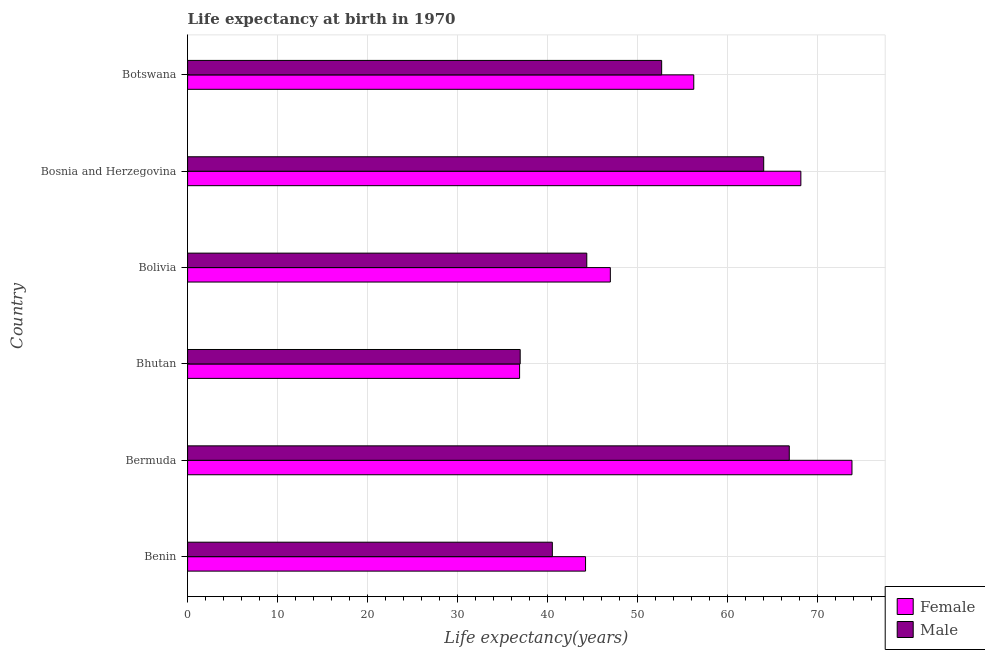How many groups of bars are there?
Your answer should be compact. 6. Are the number of bars per tick equal to the number of legend labels?
Provide a short and direct response. Yes. Are the number of bars on each tick of the Y-axis equal?
Your answer should be very brief. Yes. How many bars are there on the 5th tick from the top?
Your response must be concise. 2. What is the label of the 1st group of bars from the top?
Your answer should be very brief. Botswana. What is the life expectancy(female) in Benin?
Provide a succinct answer. 44.24. Across all countries, what is the maximum life expectancy(male)?
Provide a short and direct response. 66.89. Across all countries, what is the minimum life expectancy(male)?
Give a very brief answer. 36.97. In which country was the life expectancy(male) maximum?
Ensure brevity in your answer.  Bermuda. In which country was the life expectancy(female) minimum?
Your answer should be compact. Bhutan. What is the total life expectancy(female) in the graph?
Provide a succinct answer. 326.45. What is the difference between the life expectancy(male) in Bermuda and that in Bosnia and Herzegovina?
Give a very brief answer. 2.84. What is the difference between the life expectancy(male) in Botswana and the life expectancy(female) in Bolivia?
Give a very brief answer. 5.7. What is the average life expectancy(female) per country?
Give a very brief answer. 54.41. What is the difference between the life expectancy(male) and life expectancy(female) in Botswana?
Your answer should be very brief. -3.57. What is the ratio of the life expectancy(female) in Bosnia and Herzegovina to that in Botswana?
Provide a succinct answer. 1.21. Is the life expectancy(female) in Benin less than that in Bermuda?
Provide a short and direct response. Yes. Is the difference between the life expectancy(male) in Bosnia and Herzegovina and Botswana greater than the difference between the life expectancy(female) in Bosnia and Herzegovina and Botswana?
Give a very brief answer. No. What is the difference between the highest and the second highest life expectancy(female)?
Offer a very short reply. 5.68. What is the difference between the highest and the lowest life expectancy(female)?
Offer a terse response. 36.95. What does the 2nd bar from the bottom in Bermuda represents?
Provide a short and direct response. Male. How many bars are there?
Offer a very short reply. 12. How many countries are there in the graph?
Give a very brief answer. 6. Does the graph contain any zero values?
Make the answer very short. No. How many legend labels are there?
Your answer should be very brief. 2. What is the title of the graph?
Provide a succinct answer. Life expectancy at birth in 1970. What is the label or title of the X-axis?
Your answer should be very brief. Life expectancy(years). What is the Life expectancy(years) in Female in Benin?
Your response must be concise. 44.24. What is the Life expectancy(years) in Male in Benin?
Provide a succinct answer. 40.55. What is the Life expectancy(years) in Female in Bermuda?
Provide a short and direct response. 73.86. What is the Life expectancy(years) of Male in Bermuda?
Ensure brevity in your answer.  66.89. What is the Life expectancy(years) of Female in Bhutan?
Ensure brevity in your answer.  36.91. What is the Life expectancy(years) in Male in Bhutan?
Offer a very short reply. 36.97. What is the Life expectancy(years) in Female in Bolivia?
Keep it short and to the point. 47. What is the Life expectancy(years) in Male in Bolivia?
Your answer should be compact. 44.38. What is the Life expectancy(years) in Female in Bosnia and Herzegovina?
Provide a short and direct response. 68.18. What is the Life expectancy(years) in Male in Bosnia and Herzegovina?
Your answer should be very brief. 64.05. What is the Life expectancy(years) of Female in Botswana?
Ensure brevity in your answer.  56.27. What is the Life expectancy(years) of Male in Botswana?
Offer a very short reply. 52.7. Across all countries, what is the maximum Life expectancy(years) in Female?
Make the answer very short. 73.86. Across all countries, what is the maximum Life expectancy(years) in Male?
Your answer should be compact. 66.89. Across all countries, what is the minimum Life expectancy(years) of Female?
Make the answer very short. 36.91. Across all countries, what is the minimum Life expectancy(years) in Male?
Provide a short and direct response. 36.97. What is the total Life expectancy(years) of Female in the graph?
Your response must be concise. 326.45. What is the total Life expectancy(years) in Male in the graph?
Provide a succinct answer. 305.54. What is the difference between the Life expectancy(years) of Female in Benin and that in Bermuda?
Your answer should be very brief. -29.62. What is the difference between the Life expectancy(years) of Male in Benin and that in Bermuda?
Give a very brief answer. -26.34. What is the difference between the Life expectancy(years) in Female in Benin and that in Bhutan?
Keep it short and to the point. 7.33. What is the difference between the Life expectancy(years) in Male in Benin and that in Bhutan?
Keep it short and to the point. 3.58. What is the difference between the Life expectancy(years) in Female in Benin and that in Bolivia?
Your answer should be very brief. -2.76. What is the difference between the Life expectancy(years) in Male in Benin and that in Bolivia?
Provide a succinct answer. -3.83. What is the difference between the Life expectancy(years) in Female in Benin and that in Bosnia and Herzegovina?
Your response must be concise. -23.94. What is the difference between the Life expectancy(years) of Male in Benin and that in Bosnia and Herzegovina?
Offer a very short reply. -23.5. What is the difference between the Life expectancy(years) of Female in Benin and that in Botswana?
Make the answer very short. -12.03. What is the difference between the Life expectancy(years) of Male in Benin and that in Botswana?
Provide a short and direct response. -12.15. What is the difference between the Life expectancy(years) of Female in Bermuda and that in Bhutan?
Provide a short and direct response. 36.95. What is the difference between the Life expectancy(years) in Male in Bermuda and that in Bhutan?
Offer a very short reply. 29.92. What is the difference between the Life expectancy(years) of Female in Bermuda and that in Bolivia?
Give a very brief answer. 26.86. What is the difference between the Life expectancy(years) of Male in Bermuda and that in Bolivia?
Make the answer very short. 22.51. What is the difference between the Life expectancy(years) of Female in Bermuda and that in Bosnia and Herzegovina?
Offer a very short reply. 5.68. What is the difference between the Life expectancy(years) in Male in Bermuda and that in Bosnia and Herzegovina?
Provide a succinct answer. 2.84. What is the difference between the Life expectancy(years) in Female in Bermuda and that in Botswana?
Your answer should be compact. 17.59. What is the difference between the Life expectancy(years) of Male in Bermuda and that in Botswana?
Your answer should be compact. 14.19. What is the difference between the Life expectancy(years) of Female in Bhutan and that in Bolivia?
Your answer should be very brief. -10.09. What is the difference between the Life expectancy(years) of Male in Bhutan and that in Bolivia?
Offer a terse response. -7.4. What is the difference between the Life expectancy(years) of Female in Bhutan and that in Bosnia and Herzegovina?
Ensure brevity in your answer.  -31.27. What is the difference between the Life expectancy(years) in Male in Bhutan and that in Bosnia and Herzegovina?
Keep it short and to the point. -27.07. What is the difference between the Life expectancy(years) in Female in Bhutan and that in Botswana?
Ensure brevity in your answer.  -19.36. What is the difference between the Life expectancy(years) in Male in Bhutan and that in Botswana?
Provide a succinct answer. -15.73. What is the difference between the Life expectancy(years) in Female in Bolivia and that in Bosnia and Herzegovina?
Keep it short and to the point. -21.18. What is the difference between the Life expectancy(years) of Male in Bolivia and that in Bosnia and Herzegovina?
Your answer should be compact. -19.67. What is the difference between the Life expectancy(years) of Female in Bolivia and that in Botswana?
Your response must be concise. -9.28. What is the difference between the Life expectancy(years) in Male in Bolivia and that in Botswana?
Give a very brief answer. -8.32. What is the difference between the Life expectancy(years) in Female in Bosnia and Herzegovina and that in Botswana?
Keep it short and to the point. 11.9. What is the difference between the Life expectancy(years) in Male in Bosnia and Herzegovina and that in Botswana?
Offer a terse response. 11.35. What is the difference between the Life expectancy(years) of Female in Benin and the Life expectancy(years) of Male in Bermuda?
Ensure brevity in your answer.  -22.65. What is the difference between the Life expectancy(years) in Female in Benin and the Life expectancy(years) in Male in Bhutan?
Your response must be concise. 7.27. What is the difference between the Life expectancy(years) in Female in Benin and the Life expectancy(years) in Male in Bolivia?
Give a very brief answer. -0.14. What is the difference between the Life expectancy(years) of Female in Benin and the Life expectancy(years) of Male in Bosnia and Herzegovina?
Your answer should be very brief. -19.81. What is the difference between the Life expectancy(years) of Female in Benin and the Life expectancy(years) of Male in Botswana?
Ensure brevity in your answer.  -8.46. What is the difference between the Life expectancy(years) of Female in Bermuda and the Life expectancy(years) of Male in Bhutan?
Provide a succinct answer. 36.89. What is the difference between the Life expectancy(years) of Female in Bermuda and the Life expectancy(years) of Male in Bolivia?
Your response must be concise. 29.48. What is the difference between the Life expectancy(years) in Female in Bermuda and the Life expectancy(years) in Male in Bosnia and Herzegovina?
Your answer should be very brief. 9.81. What is the difference between the Life expectancy(years) of Female in Bermuda and the Life expectancy(years) of Male in Botswana?
Provide a succinct answer. 21.16. What is the difference between the Life expectancy(years) in Female in Bhutan and the Life expectancy(years) in Male in Bolivia?
Your answer should be compact. -7.47. What is the difference between the Life expectancy(years) of Female in Bhutan and the Life expectancy(years) of Male in Bosnia and Herzegovina?
Ensure brevity in your answer.  -27.14. What is the difference between the Life expectancy(years) of Female in Bhutan and the Life expectancy(years) of Male in Botswana?
Ensure brevity in your answer.  -15.79. What is the difference between the Life expectancy(years) in Female in Bolivia and the Life expectancy(years) in Male in Bosnia and Herzegovina?
Offer a very short reply. -17.05. What is the difference between the Life expectancy(years) of Female in Bolivia and the Life expectancy(years) of Male in Botswana?
Your answer should be very brief. -5.71. What is the difference between the Life expectancy(years) in Female in Bosnia and Herzegovina and the Life expectancy(years) in Male in Botswana?
Offer a very short reply. 15.47. What is the average Life expectancy(years) of Female per country?
Make the answer very short. 54.41. What is the average Life expectancy(years) of Male per country?
Your answer should be compact. 50.92. What is the difference between the Life expectancy(years) of Female and Life expectancy(years) of Male in Benin?
Provide a succinct answer. 3.69. What is the difference between the Life expectancy(years) of Female and Life expectancy(years) of Male in Bermuda?
Offer a very short reply. 6.97. What is the difference between the Life expectancy(years) in Female and Life expectancy(years) in Male in Bhutan?
Make the answer very short. -0.07. What is the difference between the Life expectancy(years) of Female and Life expectancy(years) of Male in Bolivia?
Make the answer very short. 2.62. What is the difference between the Life expectancy(years) in Female and Life expectancy(years) in Male in Bosnia and Herzegovina?
Your answer should be compact. 4.13. What is the difference between the Life expectancy(years) in Female and Life expectancy(years) in Male in Botswana?
Keep it short and to the point. 3.57. What is the ratio of the Life expectancy(years) of Female in Benin to that in Bermuda?
Offer a terse response. 0.6. What is the ratio of the Life expectancy(years) in Male in Benin to that in Bermuda?
Keep it short and to the point. 0.61. What is the ratio of the Life expectancy(years) of Female in Benin to that in Bhutan?
Offer a terse response. 1.2. What is the ratio of the Life expectancy(years) of Male in Benin to that in Bhutan?
Offer a very short reply. 1.1. What is the ratio of the Life expectancy(years) of Female in Benin to that in Bolivia?
Your answer should be very brief. 0.94. What is the ratio of the Life expectancy(years) in Male in Benin to that in Bolivia?
Offer a terse response. 0.91. What is the ratio of the Life expectancy(years) of Female in Benin to that in Bosnia and Herzegovina?
Make the answer very short. 0.65. What is the ratio of the Life expectancy(years) of Male in Benin to that in Bosnia and Herzegovina?
Give a very brief answer. 0.63. What is the ratio of the Life expectancy(years) of Female in Benin to that in Botswana?
Your answer should be compact. 0.79. What is the ratio of the Life expectancy(years) of Male in Benin to that in Botswana?
Give a very brief answer. 0.77. What is the ratio of the Life expectancy(years) in Female in Bermuda to that in Bhutan?
Provide a short and direct response. 2. What is the ratio of the Life expectancy(years) in Male in Bermuda to that in Bhutan?
Offer a terse response. 1.81. What is the ratio of the Life expectancy(years) in Female in Bermuda to that in Bolivia?
Give a very brief answer. 1.57. What is the ratio of the Life expectancy(years) in Male in Bermuda to that in Bolivia?
Make the answer very short. 1.51. What is the ratio of the Life expectancy(years) in Female in Bermuda to that in Bosnia and Herzegovina?
Ensure brevity in your answer.  1.08. What is the ratio of the Life expectancy(years) in Male in Bermuda to that in Bosnia and Herzegovina?
Offer a terse response. 1.04. What is the ratio of the Life expectancy(years) of Female in Bermuda to that in Botswana?
Make the answer very short. 1.31. What is the ratio of the Life expectancy(years) of Male in Bermuda to that in Botswana?
Your answer should be very brief. 1.27. What is the ratio of the Life expectancy(years) in Female in Bhutan to that in Bolivia?
Your response must be concise. 0.79. What is the ratio of the Life expectancy(years) of Male in Bhutan to that in Bolivia?
Keep it short and to the point. 0.83. What is the ratio of the Life expectancy(years) of Female in Bhutan to that in Bosnia and Herzegovina?
Your response must be concise. 0.54. What is the ratio of the Life expectancy(years) of Male in Bhutan to that in Bosnia and Herzegovina?
Keep it short and to the point. 0.58. What is the ratio of the Life expectancy(years) of Female in Bhutan to that in Botswana?
Your response must be concise. 0.66. What is the ratio of the Life expectancy(years) in Male in Bhutan to that in Botswana?
Provide a short and direct response. 0.7. What is the ratio of the Life expectancy(years) in Female in Bolivia to that in Bosnia and Herzegovina?
Keep it short and to the point. 0.69. What is the ratio of the Life expectancy(years) of Male in Bolivia to that in Bosnia and Herzegovina?
Your answer should be compact. 0.69. What is the ratio of the Life expectancy(years) of Female in Bolivia to that in Botswana?
Offer a terse response. 0.84. What is the ratio of the Life expectancy(years) of Male in Bolivia to that in Botswana?
Your response must be concise. 0.84. What is the ratio of the Life expectancy(years) in Female in Bosnia and Herzegovina to that in Botswana?
Give a very brief answer. 1.21. What is the ratio of the Life expectancy(years) in Male in Bosnia and Herzegovina to that in Botswana?
Offer a very short reply. 1.22. What is the difference between the highest and the second highest Life expectancy(years) of Female?
Your response must be concise. 5.68. What is the difference between the highest and the second highest Life expectancy(years) in Male?
Your answer should be compact. 2.84. What is the difference between the highest and the lowest Life expectancy(years) of Female?
Your response must be concise. 36.95. What is the difference between the highest and the lowest Life expectancy(years) in Male?
Provide a succinct answer. 29.92. 